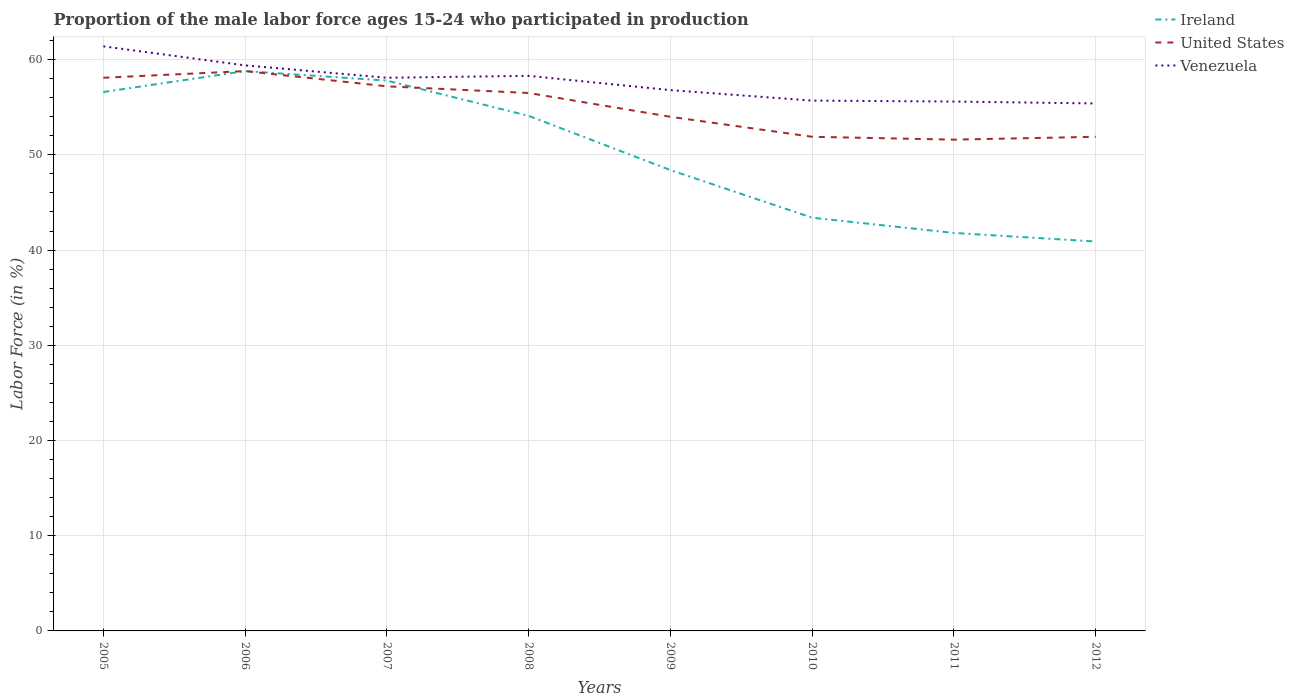Does the line corresponding to United States intersect with the line corresponding to Venezuela?
Ensure brevity in your answer.  No. Across all years, what is the maximum proportion of the male labor force who participated in production in United States?
Give a very brief answer. 51.6. What is the total proportion of the male labor force who participated in production in Ireland in the graph?
Your answer should be very brief. 6.6. What is the difference between the highest and the second highest proportion of the male labor force who participated in production in Venezuela?
Provide a succinct answer. 6. Is the proportion of the male labor force who participated in production in Venezuela strictly greater than the proportion of the male labor force who participated in production in Ireland over the years?
Keep it short and to the point. No. How many lines are there?
Give a very brief answer. 3. How are the legend labels stacked?
Give a very brief answer. Vertical. What is the title of the graph?
Give a very brief answer. Proportion of the male labor force ages 15-24 who participated in production. What is the Labor Force (in %) in Ireland in 2005?
Your answer should be compact. 56.6. What is the Labor Force (in %) of United States in 2005?
Ensure brevity in your answer.  58.1. What is the Labor Force (in %) of Venezuela in 2005?
Offer a very short reply. 61.4. What is the Labor Force (in %) in Ireland in 2006?
Offer a very short reply. 58.8. What is the Labor Force (in %) of United States in 2006?
Make the answer very short. 58.8. What is the Labor Force (in %) in Venezuela in 2006?
Offer a terse response. 59.4. What is the Labor Force (in %) of Ireland in 2007?
Provide a succinct answer. 57.8. What is the Labor Force (in %) of United States in 2007?
Your response must be concise. 57.2. What is the Labor Force (in %) of Venezuela in 2007?
Provide a succinct answer. 58.1. What is the Labor Force (in %) in Ireland in 2008?
Provide a succinct answer. 54.1. What is the Labor Force (in %) of United States in 2008?
Ensure brevity in your answer.  56.5. What is the Labor Force (in %) of Venezuela in 2008?
Offer a very short reply. 58.3. What is the Labor Force (in %) of Ireland in 2009?
Provide a succinct answer. 48.4. What is the Labor Force (in %) in Venezuela in 2009?
Your response must be concise. 56.8. What is the Labor Force (in %) of Ireland in 2010?
Your answer should be compact. 43.4. What is the Labor Force (in %) in United States in 2010?
Give a very brief answer. 51.9. What is the Labor Force (in %) in Venezuela in 2010?
Provide a succinct answer. 55.7. What is the Labor Force (in %) in Ireland in 2011?
Ensure brevity in your answer.  41.8. What is the Labor Force (in %) of United States in 2011?
Give a very brief answer. 51.6. What is the Labor Force (in %) of Venezuela in 2011?
Offer a terse response. 55.6. What is the Labor Force (in %) in Ireland in 2012?
Your answer should be compact. 40.9. What is the Labor Force (in %) in United States in 2012?
Keep it short and to the point. 51.9. What is the Labor Force (in %) in Venezuela in 2012?
Provide a short and direct response. 55.4. Across all years, what is the maximum Labor Force (in %) in Ireland?
Your answer should be compact. 58.8. Across all years, what is the maximum Labor Force (in %) of United States?
Offer a terse response. 58.8. Across all years, what is the maximum Labor Force (in %) of Venezuela?
Provide a succinct answer. 61.4. Across all years, what is the minimum Labor Force (in %) in Ireland?
Offer a very short reply. 40.9. Across all years, what is the minimum Labor Force (in %) in United States?
Make the answer very short. 51.6. Across all years, what is the minimum Labor Force (in %) in Venezuela?
Offer a very short reply. 55.4. What is the total Labor Force (in %) of Ireland in the graph?
Your response must be concise. 401.8. What is the total Labor Force (in %) in United States in the graph?
Give a very brief answer. 440. What is the total Labor Force (in %) in Venezuela in the graph?
Make the answer very short. 460.7. What is the difference between the Labor Force (in %) of United States in 2005 and that in 2006?
Offer a terse response. -0.7. What is the difference between the Labor Force (in %) in Venezuela in 2005 and that in 2007?
Your answer should be very brief. 3.3. What is the difference between the Labor Force (in %) of Ireland in 2005 and that in 2009?
Offer a very short reply. 8.2. What is the difference between the Labor Force (in %) of United States in 2005 and that in 2009?
Provide a succinct answer. 4.1. What is the difference between the Labor Force (in %) in Venezuela in 2005 and that in 2009?
Provide a short and direct response. 4.6. What is the difference between the Labor Force (in %) in United States in 2005 and that in 2010?
Offer a terse response. 6.2. What is the difference between the Labor Force (in %) of Venezuela in 2005 and that in 2010?
Give a very brief answer. 5.7. What is the difference between the Labor Force (in %) of United States in 2005 and that in 2011?
Keep it short and to the point. 6.5. What is the difference between the Labor Force (in %) of Ireland in 2005 and that in 2012?
Offer a terse response. 15.7. What is the difference between the Labor Force (in %) of United States in 2005 and that in 2012?
Provide a short and direct response. 6.2. What is the difference between the Labor Force (in %) in Ireland in 2006 and that in 2007?
Provide a short and direct response. 1. What is the difference between the Labor Force (in %) in United States in 2006 and that in 2007?
Provide a short and direct response. 1.6. What is the difference between the Labor Force (in %) of Venezuela in 2006 and that in 2007?
Give a very brief answer. 1.3. What is the difference between the Labor Force (in %) in United States in 2006 and that in 2008?
Your answer should be very brief. 2.3. What is the difference between the Labor Force (in %) of United States in 2006 and that in 2009?
Offer a very short reply. 4.8. What is the difference between the Labor Force (in %) of Venezuela in 2006 and that in 2009?
Your answer should be compact. 2.6. What is the difference between the Labor Force (in %) in Ireland in 2006 and that in 2011?
Make the answer very short. 17. What is the difference between the Labor Force (in %) in United States in 2006 and that in 2011?
Your response must be concise. 7.2. What is the difference between the Labor Force (in %) in Venezuela in 2006 and that in 2011?
Offer a terse response. 3.8. What is the difference between the Labor Force (in %) of Ireland in 2006 and that in 2012?
Your answer should be compact. 17.9. What is the difference between the Labor Force (in %) of United States in 2006 and that in 2012?
Give a very brief answer. 6.9. What is the difference between the Labor Force (in %) of Venezuela in 2006 and that in 2012?
Provide a succinct answer. 4. What is the difference between the Labor Force (in %) of Ireland in 2007 and that in 2009?
Your answer should be compact. 9.4. What is the difference between the Labor Force (in %) of United States in 2007 and that in 2009?
Provide a short and direct response. 3.2. What is the difference between the Labor Force (in %) in Venezuela in 2007 and that in 2009?
Your answer should be very brief. 1.3. What is the difference between the Labor Force (in %) in Venezuela in 2007 and that in 2010?
Ensure brevity in your answer.  2.4. What is the difference between the Labor Force (in %) of United States in 2007 and that in 2011?
Your answer should be very brief. 5.6. What is the difference between the Labor Force (in %) in United States in 2007 and that in 2012?
Keep it short and to the point. 5.3. What is the difference between the Labor Force (in %) in Venezuela in 2007 and that in 2012?
Ensure brevity in your answer.  2.7. What is the difference between the Labor Force (in %) of Venezuela in 2008 and that in 2010?
Your answer should be compact. 2.6. What is the difference between the Labor Force (in %) of Ireland in 2008 and that in 2011?
Your response must be concise. 12.3. What is the difference between the Labor Force (in %) in Ireland in 2009 and that in 2010?
Keep it short and to the point. 5. What is the difference between the Labor Force (in %) in Venezuela in 2009 and that in 2010?
Offer a very short reply. 1.1. What is the difference between the Labor Force (in %) of Ireland in 2009 and that in 2011?
Ensure brevity in your answer.  6.6. What is the difference between the Labor Force (in %) of United States in 2009 and that in 2011?
Give a very brief answer. 2.4. What is the difference between the Labor Force (in %) of Venezuela in 2009 and that in 2011?
Your answer should be compact. 1.2. What is the difference between the Labor Force (in %) in Ireland in 2010 and that in 2011?
Provide a succinct answer. 1.6. What is the difference between the Labor Force (in %) of United States in 2011 and that in 2012?
Offer a very short reply. -0.3. What is the difference between the Labor Force (in %) in Venezuela in 2011 and that in 2012?
Offer a terse response. 0.2. What is the difference between the Labor Force (in %) of Ireland in 2005 and the Labor Force (in %) of United States in 2006?
Make the answer very short. -2.2. What is the difference between the Labor Force (in %) of Ireland in 2005 and the Labor Force (in %) of United States in 2007?
Make the answer very short. -0.6. What is the difference between the Labor Force (in %) in United States in 2005 and the Labor Force (in %) in Venezuela in 2007?
Make the answer very short. 0. What is the difference between the Labor Force (in %) in Ireland in 2005 and the Labor Force (in %) in Venezuela in 2008?
Ensure brevity in your answer.  -1.7. What is the difference between the Labor Force (in %) in Ireland in 2005 and the Labor Force (in %) in United States in 2009?
Provide a succinct answer. 2.6. What is the difference between the Labor Force (in %) in Ireland in 2005 and the Labor Force (in %) in Venezuela in 2009?
Keep it short and to the point. -0.2. What is the difference between the Labor Force (in %) in United States in 2005 and the Labor Force (in %) in Venezuela in 2009?
Your response must be concise. 1.3. What is the difference between the Labor Force (in %) in United States in 2005 and the Labor Force (in %) in Venezuela in 2010?
Keep it short and to the point. 2.4. What is the difference between the Labor Force (in %) in Ireland in 2005 and the Labor Force (in %) in Venezuela in 2011?
Offer a very short reply. 1. What is the difference between the Labor Force (in %) in United States in 2005 and the Labor Force (in %) in Venezuela in 2011?
Your answer should be very brief. 2.5. What is the difference between the Labor Force (in %) of Ireland in 2005 and the Labor Force (in %) of United States in 2012?
Your answer should be very brief. 4.7. What is the difference between the Labor Force (in %) of Ireland in 2005 and the Labor Force (in %) of Venezuela in 2012?
Provide a short and direct response. 1.2. What is the difference between the Labor Force (in %) in Ireland in 2006 and the Labor Force (in %) in United States in 2007?
Offer a terse response. 1.6. What is the difference between the Labor Force (in %) of Ireland in 2006 and the Labor Force (in %) of Venezuela in 2007?
Provide a short and direct response. 0.7. What is the difference between the Labor Force (in %) in United States in 2006 and the Labor Force (in %) in Venezuela in 2008?
Your response must be concise. 0.5. What is the difference between the Labor Force (in %) in Ireland in 2006 and the Labor Force (in %) in Venezuela in 2009?
Offer a terse response. 2. What is the difference between the Labor Force (in %) of United States in 2006 and the Labor Force (in %) of Venezuela in 2009?
Your answer should be very brief. 2. What is the difference between the Labor Force (in %) of United States in 2006 and the Labor Force (in %) of Venezuela in 2010?
Keep it short and to the point. 3.1. What is the difference between the Labor Force (in %) of Ireland in 2006 and the Labor Force (in %) of United States in 2012?
Offer a very short reply. 6.9. What is the difference between the Labor Force (in %) of United States in 2006 and the Labor Force (in %) of Venezuela in 2012?
Your answer should be very brief. 3.4. What is the difference between the Labor Force (in %) of Ireland in 2007 and the Labor Force (in %) of United States in 2008?
Your answer should be compact. 1.3. What is the difference between the Labor Force (in %) in Ireland in 2007 and the Labor Force (in %) in Venezuela in 2008?
Provide a short and direct response. -0.5. What is the difference between the Labor Force (in %) of United States in 2007 and the Labor Force (in %) of Venezuela in 2008?
Keep it short and to the point. -1.1. What is the difference between the Labor Force (in %) of Ireland in 2007 and the Labor Force (in %) of Venezuela in 2009?
Your answer should be very brief. 1. What is the difference between the Labor Force (in %) of United States in 2007 and the Labor Force (in %) of Venezuela in 2009?
Offer a very short reply. 0.4. What is the difference between the Labor Force (in %) of Ireland in 2007 and the Labor Force (in %) of United States in 2010?
Your response must be concise. 5.9. What is the difference between the Labor Force (in %) of Ireland in 2007 and the Labor Force (in %) of Venezuela in 2010?
Your answer should be very brief. 2.1. What is the difference between the Labor Force (in %) of United States in 2007 and the Labor Force (in %) of Venezuela in 2010?
Your answer should be compact. 1.5. What is the difference between the Labor Force (in %) of Ireland in 2007 and the Labor Force (in %) of United States in 2011?
Offer a terse response. 6.2. What is the difference between the Labor Force (in %) in United States in 2007 and the Labor Force (in %) in Venezuela in 2011?
Your answer should be compact. 1.6. What is the difference between the Labor Force (in %) in Ireland in 2007 and the Labor Force (in %) in Venezuela in 2012?
Keep it short and to the point. 2.4. What is the difference between the Labor Force (in %) of Ireland in 2008 and the Labor Force (in %) of United States in 2010?
Keep it short and to the point. 2.2. What is the difference between the Labor Force (in %) of Ireland in 2008 and the Labor Force (in %) of Venezuela in 2010?
Your answer should be compact. -1.6. What is the difference between the Labor Force (in %) in United States in 2008 and the Labor Force (in %) in Venezuela in 2010?
Provide a short and direct response. 0.8. What is the difference between the Labor Force (in %) of Ireland in 2008 and the Labor Force (in %) of Venezuela in 2011?
Provide a succinct answer. -1.5. What is the difference between the Labor Force (in %) in Ireland in 2008 and the Labor Force (in %) in United States in 2012?
Offer a very short reply. 2.2. What is the difference between the Labor Force (in %) in Ireland in 2008 and the Labor Force (in %) in Venezuela in 2012?
Your answer should be compact. -1.3. What is the difference between the Labor Force (in %) in Ireland in 2009 and the Labor Force (in %) in United States in 2010?
Offer a very short reply. -3.5. What is the difference between the Labor Force (in %) of Ireland in 2009 and the Labor Force (in %) of United States in 2011?
Ensure brevity in your answer.  -3.2. What is the difference between the Labor Force (in %) of Ireland in 2009 and the Labor Force (in %) of Venezuela in 2011?
Your answer should be compact. -7.2. What is the difference between the Labor Force (in %) in United States in 2009 and the Labor Force (in %) in Venezuela in 2012?
Your answer should be very brief. -1.4. What is the difference between the Labor Force (in %) of United States in 2010 and the Labor Force (in %) of Venezuela in 2011?
Provide a succinct answer. -3.7. What is the difference between the Labor Force (in %) of Ireland in 2010 and the Labor Force (in %) of United States in 2012?
Your answer should be compact. -8.5. What is the difference between the Labor Force (in %) in Ireland in 2011 and the Labor Force (in %) in United States in 2012?
Your response must be concise. -10.1. What is the difference between the Labor Force (in %) of Ireland in 2011 and the Labor Force (in %) of Venezuela in 2012?
Your response must be concise. -13.6. What is the difference between the Labor Force (in %) in United States in 2011 and the Labor Force (in %) in Venezuela in 2012?
Provide a succinct answer. -3.8. What is the average Labor Force (in %) of Ireland per year?
Your answer should be very brief. 50.23. What is the average Labor Force (in %) of Venezuela per year?
Provide a short and direct response. 57.59. In the year 2005, what is the difference between the Labor Force (in %) in Ireland and Labor Force (in %) in Venezuela?
Your response must be concise. -4.8. In the year 2006, what is the difference between the Labor Force (in %) in Ireland and Labor Force (in %) in United States?
Your answer should be very brief. 0. In the year 2007, what is the difference between the Labor Force (in %) of Ireland and Labor Force (in %) of Venezuela?
Provide a short and direct response. -0.3. In the year 2008, what is the difference between the Labor Force (in %) of United States and Labor Force (in %) of Venezuela?
Your response must be concise. -1.8. In the year 2010, what is the difference between the Labor Force (in %) in Ireland and Labor Force (in %) in United States?
Give a very brief answer. -8.5. In the year 2011, what is the difference between the Labor Force (in %) of Ireland and Labor Force (in %) of United States?
Provide a short and direct response. -9.8. In the year 2012, what is the difference between the Labor Force (in %) of Ireland and Labor Force (in %) of United States?
Make the answer very short. -11. In the year 2012, what is the difference between the Labor Force (in %) of United States and Labor Force (in %) of Venezuela?
Keep it short and to the point. -3.5. What is the ratio of the Labor Force (in %) in Ireland in 2005 to that in 2006?
Provide a short and direct response. 0.96. What is the ratio of the Labor Force (in %) of United States in 2005 to that in 2006?
Make the answer very short. 0.99. What is the ratio of the Labor Force (in %) of Venezuela in 2005 to that in 2006?
Ensure brevity in your answer.  1.03. What is the ratio of the Labor Force (in %) in Ireland in 2005 to that in 2007?
Offer a very short reply. 0.98. What is the ratio of the Labor Force (in %) of United States in 2005 to that in 2007?
Your answer should be very brief. 1.02. What is the ratio of the Labor Force (in %) of Venezuela in 2005 to that in 2007?
Give a very brief answer. 1.06. What is the ratio of the Labor Force (in %) in Ireland in 2005 to that in 2008?
Your response must be concise. 1.05. What is the ratio of the Labor Force (in %) in United States in 2005 to that in 2008?
Your response must be concise. 1.03. What is the ratio of the Labor Force (in %) of Venezuela in 2005 to that in 2008?
Offer a very short reply. 1.05. What is the ratio of the Labor Force (in %) of Ireland in 2005 to that in 2009?
Offer a very short reply. 1.17. What is the ratio of the Labor Force (in %) of United States in 2005 to that in 2009?
Offer a terse response. 1.08. What is the ratio of the Labor Force (in %) in Venezuela in 2005 to that in 2009?
Provide a short and direct response. 1.08. What is the ratio of the Labor Force (in %) of Ireland in 2005 to that in 2010?
Give a very brief answer. 1.3. What is the ratio of the Labor Force (in %) in United States in 2005 to that in 2010?
Your response must be concise. 1.12. What is the ratio of the Labor Force (in %) in Venezuela in 2005 to that in 2010?
Ensure brevity in your answer.  1.1. What is the ratio of the Labor Force (in %) of Ireland in 2005 to that in 2011?
Your answer should be compact. 1.35. What is the ratio of the Labor Force (in %) of United States in 2005 to that in 2011?
Provide a succinct answer. 1.13. What is the ratio of the Labor Force (in %) in Venezuela in 2005 to that in 2011?
Offer a terse response. 1.1. What is the ratio of the Labor Force (in %) in Ireland in 2005 to that in 2012?
Provide a succinct answer. 1.38. What is the ratio of the Labor Force (in %) of United States in 2005 to that in 2012?
Offer a very short reply. 1.12. What is the ratio of the Labor Force (in %) of Venezuela in 2005 to that in 2012?
Make the answer very short. 1.11. What is the ratio of the Labor Force (in %) in Ireland in 2006 to that in 2007?
Ensure brevity in your answer.  1.02. What is the ratio of the Labor Force (in %) in United States in 2006 to that in 2007?
Make the answer very short. 1.03. What is the ratio of the Labor Force (in %) of Venezuela in 2006 to that in 2007?
Provide a succinct answer. 1.02. What is the ratio of the Labor Force (in %) in Ireland in 2006 to that in 2008?
Your answer should be compact. 1.09. What is the ratio of the Labor Force (in %) in United States in 2006 to that in 2008?
Make the answer very short. 1.04. What is the ratio of the Labor Force (in %) in Venezuela in 2006 to that in 2008?
Your answer should be very brief. 1.02. What is the ratio of the Labor Force (in %) in Ireland in 2006 to that in 2009?
Your answer should be very brief. 1.21. What is the ratio of the Labor Force (in %) of United States in 2006 to that in 2009?
Give a very brief answer. 1.09. What is the ratio of the Labor Force (in %) of Venezuela in 2006 to that in 2009?
Provide a succinct answer. 1.05. What is the ratio of the Labor Force (in %) of Ireland in 2006 to that in 2010?
Keep it short and to the point. 1.35. What is the ratio of the Labor Force (in %) in United States in 2006 to that in 2010?
Provide a succinct answer. 1.13. What is the ratio of the Labor Force (in %) in Venezuela in 2006 to that in 2010?
Offer a very short reply. 1.07. What is the ratio of the Labor Force (in %) of Ireland in 2006 to that in 2011?
Offer a terse response. 1.41. What is the ratio of the Labor Force (in %) in United States in 2006 to that in 2011?
Your answer should be very brief. 1.14. What is the ratio of the Labor Force (in %) of Venezuela in 2006 to that in 2011?
Provide a short and direct response. 1.07. What is the ratio of the Labor Force (in %) in Ireland in 2006 to that in 2012?
Your response must be concise. 1.44. What is the ratio of the Labor Force (in %) in United States in 2006 to that in 2012?
Provide a short and direct response. 1.13. What is the ratio of the Labor Force (in %) of Venezuela in 2006 to that in 2012?
Provide a succinct answer. 1.07. What is the ratio of the Labor Force (in %) of Ireland in 2007 to that in 2008?
Your response must be concise. 1.07. What is the ratio of the Labor Force (in %) of United States in 2007 to that in 2008?
Your answer should be very brief. 1.01. What is the ratio of the Labor Force (in %) in Venezuela in 2007 to that in 2008?
Provide a short and direct response. 1. What is the ratio of the Labor Force (in %) of Ireland in 2007 to that in 2009?
Ensure brevity in your answer.  1.19. What is the ratio of the Labor Force (in %) of United States in 2007 to that in 2009?
Offer a very short reply. 1.06. What is the ratio of the Labor Force (in %) of Venezuela in 2007 to that in 2009?
Your answer should be compact. 1.02. What is the ratio of the Labor Force (in %) of Ireland in 2007 to that in 2010?
Make the answer very short. 1.33. What is the ratio of the Labor Force (in %) of United States in 2007 to that in 2010?
Keep it short and to the point. 1.1. What is the ratio of the Labor Force (in %) in Venezuela in 2007 to that in 2010?
Your response must be concise. 1.04. What is the ratio of the Labor Force (in %) in Ireland in 2007 to that in 2011?
Keep it short and to the point. 1.38. What is the ratio of the Labor Force (in %) in United States in 2007 to that in 2011?
Make the answer very short. 1.11. What is the ratio of the Labor Force (in %) of Venezuela in 2007 to that in 2011?
Provide a short and direct response. 1.04. What is the ratio of the Labor Force (in %) of Ireland in 2007 to that in 2012?
Keep it short and to the point. 1.41. What is the ratio of the Labor Force (in %) of United States in 2007 to that in 2012?
Offer a terse response. 1.1. What is the ratio of the Labor Force (in %) in Venezuela in 2007 to that in 2012?
Provide a short and direct response. 1.05. What is the ratio of the Labor Force (in %) in Ireland in 2008 to that in 2009?
Provide a short and direct response. 1.12. What is the ratio of the Labor Force (in %) in United States in 2008 to that in 2009?
Your answer should be very brief. 1.05. What is the ratio of the Labor Force (in %) in Venezuela in 2008 to that in 2009?
Ensure brevity in your answer.  1.03. What is the ratio of the Labor Force (in %) of Ireland in 2008 to that in 2010?
Provide a short and direct response. 1.25. What is the ratio of the Labor Force (in %) of United States in 2008 to that in 2010?
Make the answer very short. 1.09. What is the ratio of the Labor Force (in %) of Venezuela in 2008 to that in 2010?
Provide a succinct answer. 1.05. What is the ratio of the Labor Force (in %) in Ireland in 2008 to that in 2011?
Provide a short and direct response. 1.29. What is the ratio of the Labor Force (in %) in United States in 2008 to that in 2011?
Your response must be concise. 1.09. What is the ratio of the Labor Force (in %) of Venezuela in 2008 to that in 2011?
Offer a very short reply. 1.05. What is the ratio of the Labor Force (in %) of Ireland in 2008 to that in 2012?
Your answer should be compact. 1.32. What is the ratio of the Labor Force (in %) of United States in 2008 to that in 2012?
Provide a succinct answer. 1.09. What is the ratio of the Labor Force (in %) of Venezuela in 2008 to that in 2012?
Give a very brief answer. 1.05. What is the ratio of the Labor Force (in %) of Ireland in 2009 to that in 2010?
Make the answer very short. 1.12. What is the ratio of the Labor Force (in %) of United States in 2009 to that in 2010?
Make the answer very short. 1.04. What is the ratio of the Labor Force (in %) in Venezuela in 2009 to that in 2010?
Your answer should be very brief. 1.02. What is the ratio of the Labor Force (in %) of Ireland in 2009 to that in 2011?
Ensure brevity in your answer.  1.16. What is the ratio of the Labor Force (in %) of United States in 2009 to that in 2011?
Make the answer very short. 1.05. What is the ratio of the Labor Force (in %) of Venezuela in 2009 to that in 2011?
Your answer should be very brief. 1.02. What is the ratio of the Labor Force (in %) in Ireland in 2009 to that in 2012?
Your response must be concise. 1.18. What is the ratio of the Labor Force (in %) in United States in 2009 to that in 2012?
Give a very brief answer. 1.04. What is the ratio of the Labor Force (in %) of Venezuela in 2009 to that in 2012?
Provide a short and direct response. 1.03. What is the ratio of the Labor Force (in %) in Ireland in 2010 to that in 2011?
Offer a very short reply. 1.04. What is the ratio of the Labor Force (in %) in Venezuela in 2010 to that in 2011?
Ensure brevity in your answer.  1. What is the ratio of the Labor Force (in %) in Ireland in 2010 to that in 2012?
Your response must be concise. 1.06. What is the ratio of the Labor Force (in %) of Venezuela in 2010 to that in 2012?
Offer a very short reply. 1.01. What is the ratio of the Labor Force (in %) of United States in 2011 to that in 2012?
Your answer should be compact. 0.99. What is the ratio of the Labor Force (in %) of Venezuela in 2011 to that in 2012?
Your response must be concise. 1. What is the difference between the highest and the second highest Labor Force (in %) of Ireland?
Offer a very short reply. 1. What is the difference between the highest and the lowest Labor Force (in %) of Ireland?
Offer a very short reply. 17.9. 